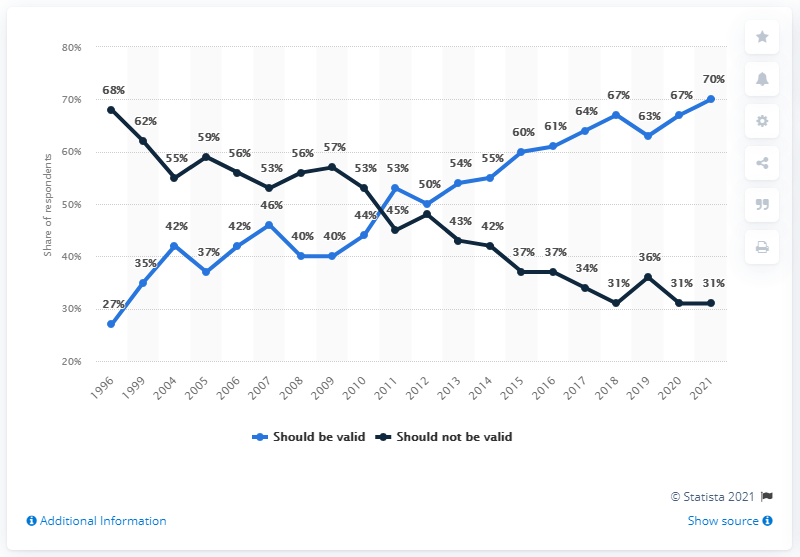Point out several critical features in this image. The difference between the highest light blue curve and the highest dark blue curve is 2. The highest percentage of the light blue curve is 70%. It is my belief that same-sex marriages should be recognized as valid in the year 2021. In 1996, a survey was conducted to determine the public's opinion on the legalization of same-sex marriages in the United States. This survey showed that the opinion on this issue has changed significantly over the years, with a significant increase in support for legalization in the 2021 survey compared to previous years. 